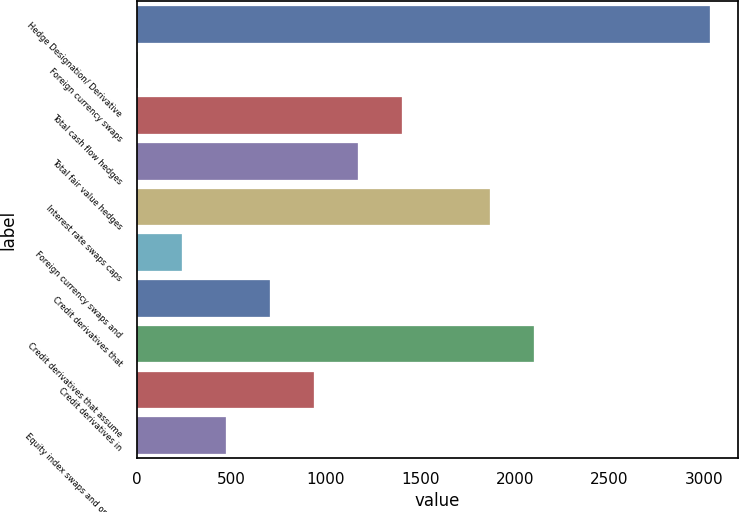<chart> <loc_0><loc_0><loc_500><loc_500><bar_chart><fcel>Hedge Designation/ Derivative<fcel>Foreign currency swaps<fcel>Total cash flow hedges<fcel>Total fair value hedges<fcel>Interest rate swaps caps<fcel>Foreign currency swaps and<fcel>Credit derivatives that<fcel>Credit derivatives that assume<fcel>Credit derivatives in<fcel>Equity index swaps and options<nl><fcel>3028.5<fcel>6<fcel>1401<fcel>1168.5<fcel>1866<fcel>238.5<fcel>703.5<fcel>2098.5<fcel>936<fcel>471<nl></chart> 